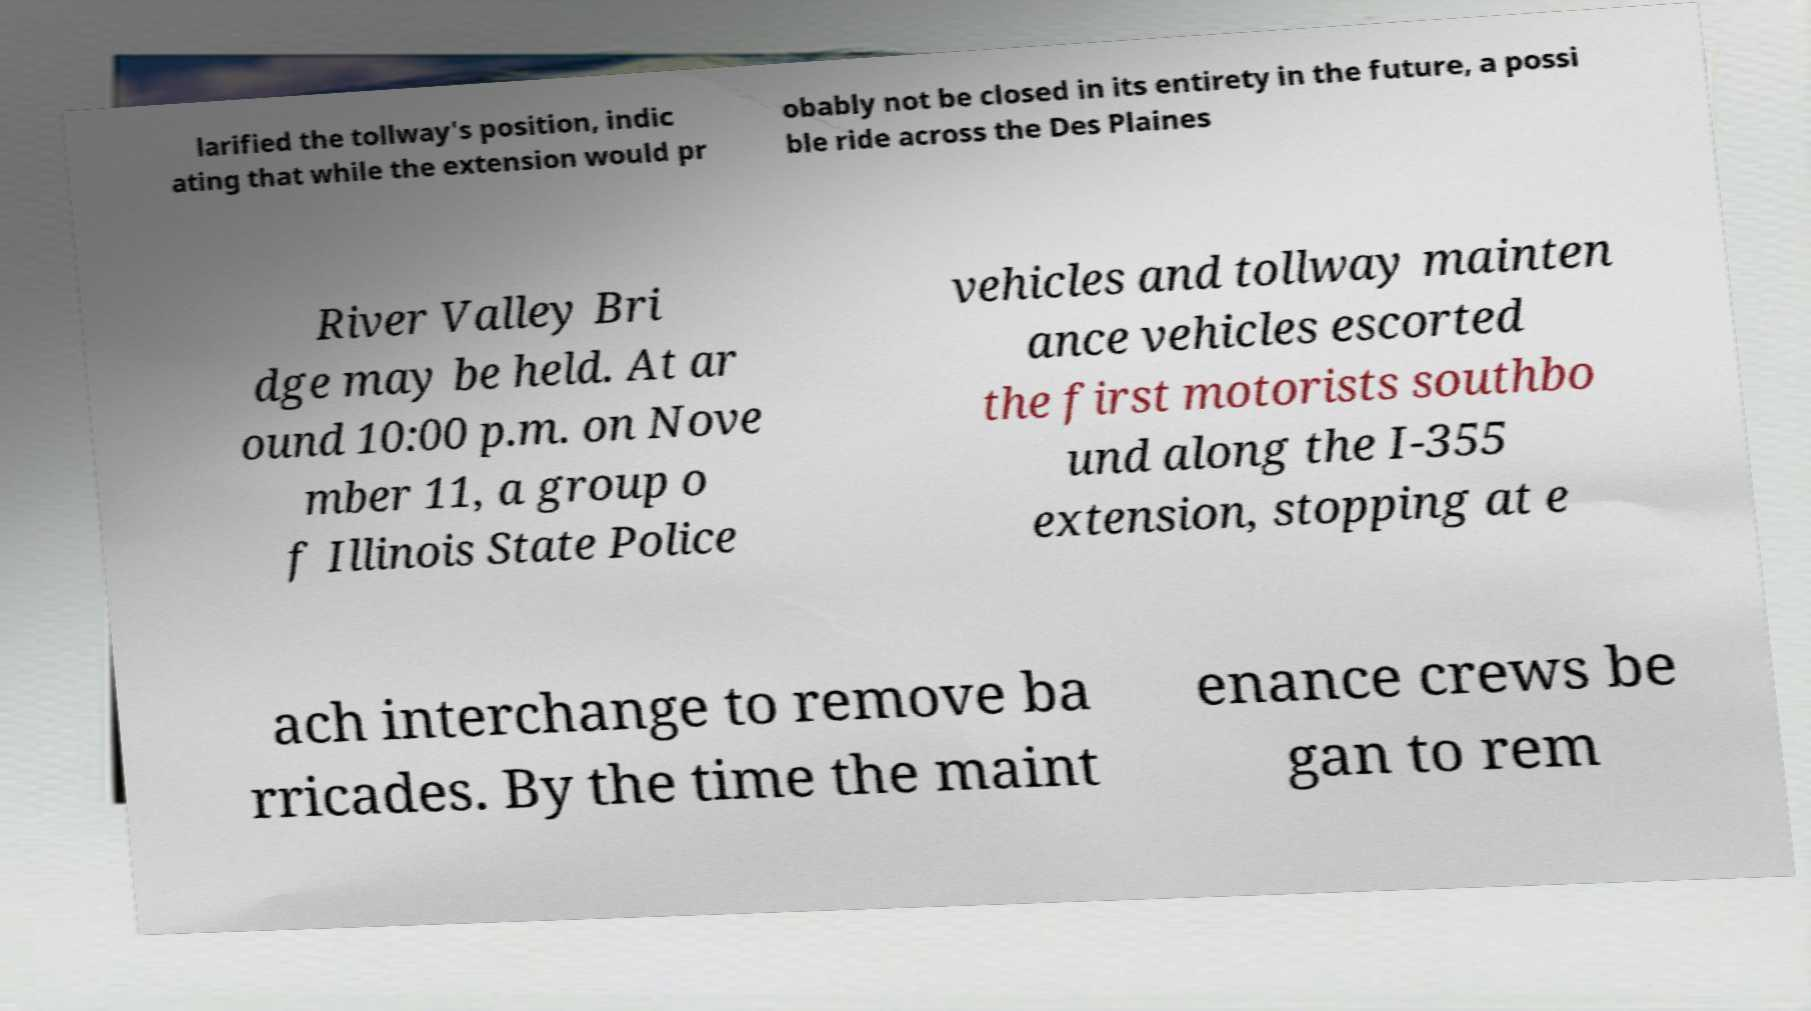Please read and relay the text visible in this image. What does it say? larified the tollway's position, indic ating that while the extension would pr obably not be closed in its entirety in the future, a possi ble ride across the Des Plaines River Valley Bri dge may be held. At ar ound 10:00 p.m. on Nove mber 11, a group o f Illinois State Police vehicles and tollway mainten ance vehicles escorted the first motorists southbo und along the I-355 extension, stopping at e ach interchange to remove ba rricades. By the time the maint enance crews be gan to rem 